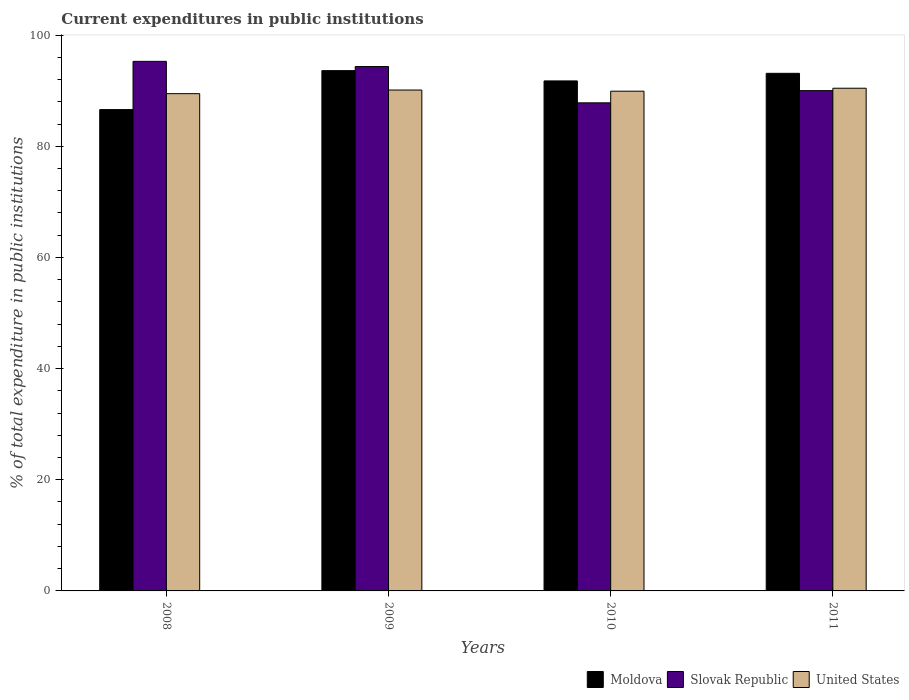How many different coloured bars are there?
Keep it short and to the point. 3. How many groups of bars are there?
Your answer should be compact. 4. How many bars are there on the 4th tick from the right?
Provide a short and direct response. 3. What is the label of the 1st group of bars from the left?
Your answer should be very brief. 2008. What is the current expenditures in public institutions in United States in 2010?
Offer a very short reply. 89.91. Across all years, what is the maximum current expenditures in public institutions in Slovak Republic?
Your answer should be very brief. 95.28. Across all years, what is the minimum current expenditures in public institutions in United States?
Offer a terse response. 89.47. In which year was the current expenditures in public institutions in Slovak Republic minimum?
Offer a very short reply. 2010. What is the total current expenditures in public institutions in United States in the graph?
Provide a succinct answer. 359.94. What is the difference between the current expenditures in public institutions in United States in 2010 and that in 2011?
Offer a very short reply. -0.53. What is the difference between the current expenditures in public institutions in Slovak Republic in 2011 and the current expenditures in public institutions in Moldova in 2008?
Provide a short and direct response. 3.41. What is the average current expenditures in public institutions in United States per year?
Provide a short and direct response. 89.99. In the year 2011, what is the difference between the current expenditures in public institutions in United States and current expenditures in public institutions in Moldova?
Your response must be concise. -2.68. What is the ratio of the current expenditures in public institutions in United States in 2010 to that in 2011?
Offer a terse response. 0.99. Is the difference between the current expenditures in public institutions in United States in 2010 and 2011 greater than the difference between the current expenditures in public institutions in Moldova in 2010 and 2011?
Provide a succinct answer. Yes. What is the difference between the highest and the second highest current expenditures in public institutions in United States?
Offer a very short reply. 0.32. What is the difference between the highest and the lowest current expenditures in public institutions in Slovak Republic?
Offer a terse response. 7.46. In how many years, is the current expenditures in public institutions in Moldova greater than the average current expenditures in public institutions in Moldova taken over all years?
Provide a short and direct response. 3. Is the sum of the current expenditures in public institutions in Slovak Republic in 2010 and 2011 greater than the maximum current expenditures in public institutions in United States across all years?
Offer a terse response. Yes. What does the 2nd bar from the left in 2009 represents?
Your response must be concise. Slovak Republic. What does the 2nd bar from the right in 2009 represents?
Your answer should be compact. Slovak Republic. How many bars are there?
Ensure brevity in your answer.  12. How many years are there in the graph?
Give a very brief answer. 4. What is the difference between two consecutive major ticks on the Y-axis?
Make the answer very short. 20. How are the legend labels stacked?
Offer a very short reply. Horizontal. What is the title of the graph?
Provide a short and direct response. Current expenditures in public institutions. Does "Guinea" appear as one of the legend labels in the graph?
Ensure brevity in your answer.  No. What is the label or title of the Y-axis?
Keep it short and to the point. % of total expenditure in public institutions. What is the % of total expenditure in public institutions of Moldova in 2008?
Your answer should be compact. 86.6. What is the % of total expenditure in public institutions of Slovak Republic in 2008?
Provide a succinct answer. 95.28. What is the % of total expenditure in public institutions of United States in 2008?
Provide a succinct answer. 89.47. What is the % of total expenditure in public institutions of Moldova in 2009?
Keep it short and to the point. 93.61. What is the % of total expenditure in public institutions of Slovak Republic in 2009?
Provide a succinct answer. 94.35. What is the % of total expenditure in public institutions of United States in 2009?
Offer a terse response. 90.12. What is the % of total expenditure in public institutions in Moldova in 2010?
Keep it short and to the point. 91.76. What is the % of total expenditure in public institutions of Slovak Republic in 2010?
Give a very brief answer. 87.82. What is the % of total expenditure in public institutions in United States in 2010?
Ensure brevity in your answer.  89.91. What is the % of total expenditure in public institutions of Moldova in 2011?
Make the answer very short. 93.13. What is the % of total expenditure in public institutions of Slovak Republic in 2011?
Provide a succinct answer. 90.01. What is the % of total expenditure in public institutions in United States in 2011?
Your answer should be compact. 90.44. Across all years, what is the maximum % of total expenditure in public institutions of Moldova?
Provide a succinct answer. 93.61. Across all years, what is the maximum % of total expenditure in public institutions in Slovak Republic?
Ensure brevity in your answer.  95.28. Across all years, what is the maximum % of total expenditure in public institutions in United States?
Ensure brevity in your answer.  90.44. Across all years, what is the minimum % of total expenditure in public institutions of Moldova?
Your answer should be compact. 86.6. Across all years, what is the minimum % of total expenditure in public institutions of Slovak Republic?
Provide a short and direct response. 87.82. Across all years, what is the minimum % of total expenditure in public institutions of United States?
Give a very brief answer. 89.47. What is the total % of total expenditure in public institutions in Moldova in the graph?
Give a very brief answer. 365.1. What is the total % of total expenditure in public institutions in Slovak Republic in the graph?
Your answer should be very brief. 367.46. What is the total % of total expenditure in public institutions in United States in the graph?
Offer a terse response. 359.94. What is the difference between the % of total expenditure in public institutions of Moldova in 2008 and that in 2009?
Ensure brevity in your answer.  -7.01. What is the difference between the % of total expenditure in public institutions in Slovak Republic in 2008 and that in 2009?
Provide a succinct answer. 0.93. What is the difference between the % of total expenditure in public institutions in United States in 2008 and that in 2009?
Your response must be concise. -0.65. What is the difference between the % of total expenditure in public institutions of Moldova in 2008 and that in 2010?
Provide a succinct answer. -5.16. What is the difference between the % of total expenditure in public institutions in Slovak Republic in 2008 and that in 2010?
Keep it short and to the point. 7.46. What is the difference between the % of total expenditure in public institutions in United States in 2008 and that in 2010?
Make the answer very short. -0.45. What is the difference between the % of total expenditure in public institutions of Moldova in 2008 and that in 2011?
Give a very brief answer. -6.53. What is the difference between the % of total expenditure in public institutions in Slovak Republic in 2008 and that in 2011?
Offer a terse response. 5.27. What is the difference between the % of total expenditure in public institutions of United States in 2008 and that in 2011?
Give a very brief answer. -0.98. What is the difference between the % of total expenditure in public institutions in Moldova in 2009 and that in 2010?
Your answer should be compact. 1.85. What is the difference between the % of total expenditure in public institutions in Slovak Republic in 2009 and that in 2010?
Offer a terse response. 6.53. What is the difference between the % of total expenditure in public institutions of United States in 2009 and that in 2010?
Your answer should be very brief. 0.21. What is the difference between the % of total expenditure in public institutions of Moldova in 2009 and that in 2011?
Ensure brevity in your answer.  0.48. What is the difference between the % of total expenditure in public institutions of Slovak Republic in 2009 and that in 2011?
Offer a very short reply. 4.33. What is the difference between the % of total expenditure in public institutions of United States in 2009 and that in 2011?
Your response must be concise. -0.32. What is the difference between the % of total expenditure in public institutions of Moldova in 2010 and that in 2011?
Provide a short and direct response. -1.37. What is the difference between the % of total expenditure in public institutions in Slovak Republic in 2010 and that in 2011?
Offer a very short reply. -2.19. What is the difference between the % of total expenditure in public institutions in United States in 2010 and that in 2011?
Make the answer very short. -0.53. What is the difference between the % of total expenditure in public institutions in Moldova in 2008 and the % of total expenditure in public institutions in Slovak Republic in 2009?
Provide a short and direct response. -7.74. What is the difference between the % of total expenditure in public institutions in Moldova in 2008 and the % of total expenditure in public institutions in United States in 2009?
Keep it short and to the point. -3.52. What is the difference between the % of total expenditure in public institutions in Slovak Republic in 2008 and the % of total expenditure in public institutions in United States in 2009?
Offer a very short reply. 5.16. What is the difference between the % of total expenditure in public institutions in Moldova in 2008 and the % of total expenditure in public institutions in Slovak Republic in 2010?
Your response must be concise. -1.22. What is the difference between the % of total expenditure in public institutions in Moldova in 2008 and the % of total expenditure in public institutions in United States in 2010?
Your response must be concise. -3.31. What is the difference between the % of total expenditure in public institutions in Slovak Republic in 2008 and the % of total expenditure in public institutions in United States in 2010?
Offer a very short reply. 5.37. What is the difference between the % of total expenditure in public institutions of Moldova in 2008 and the % of total expenditure in public institutions of Slovak Republic in 2011?
Offer a terse response. -3.41. What is the difference between the % of total expenditure in public institutions of Moldova in 2008 and the % of total expenditure in public institutions of United States in 2011?
Your answer should be very brief. -3.84. What is the difference between the % of total expenditure in public institutions of Slovak Republic in 2008 and the % of total expenditure in public institutions of United States in 2011?
Your answer should be very brief. 4.84. What is the difference between the % of total expenditure in public institutions of Moldova in 2009 and the % of total expenditure in public institutions of Slovak Republic in 2010?
Offer a very short reply. 5.79. What is the difference between the % of total expenditure in public institutions of Moldova in 2009 and the % of total expenditure in public institutions of United States in 2010?
Your answer should be very brief. 3.7. What is the difference between the % of total expenditure in public institutions in Slovak Republic in 2009 and the % of total expenditure in public institutions in United States in 2010?
Provide a short and direct response. 4.44. What is the difference between the % of total expenditure in public institutions in Moldova in 2009 and the % of total expenditure in public institutions in Slovak Republic in 2011?
Your response must be concise. 3.6. What is the difference between the % of total expenditure in public institutions in Moldova in 2009 and the % of total expenditure in public institutions in United States in 2011?
Offer a terse response. 3.17. What is the difference between the % of total expenditure in public institutions of Slovak Republic in 2009 and the % of total expenditure in public institutions of United States in 2011?
Keep it short and to the point. 3.9. What is the difference between the % of total expenditure in public institutions of Moldova in 2010 and the % of total expenditure in public institutions of Slovak Republic in 2011?
Your answer should be very brief. 1.75. What is the difference between the % of total expenditure in public institutions in Moldova in 2010 and the % of total expenditure in public institutions in United States in 2011?
Give a very brief answer. 1.32. What is the difference between the % of total expenditure in public institutions of Slovak Republic in 2010 and the % of total expenditure in public institutions of United States in 2011?
Make the answer very short. -2.63. What is the average % of total expenditure in public institutions of Moldova per year?
Your response must be concise. 91.28. What is the average % of total expenditure in public institutions of Slovak Republic per year?
Keep it short and to the point. 91.86. What is the average % of total expenditure in public institutions of United States per year?
Provide a succinct answer. 89.99. In the year 2008, what is the difference between the % of total expenditure in public institutions of Moldova and % of total expenditure in public institutions of Slovak Republic?
Your answer should be very brief. -8.68. In the year 2008, what is the difference between the % of total expenditure in public institutions in Moldova and % of total expenditure in public institutions in United States?
Provide a succinct answer. -2.86. In the year 2008, what is the difference between the % of total expenditure in public institutions in Slovak Republic and % of total expenditure in public institutions in United States?
Provide a short and direct response. 5.81. In the year 2009, what is the difference between the % of total expenditure in public institutions in Moldova and % of total expenditure in public institutions in Slovak Republic?
Provide a succinct answer. -0.74. In the year 2009, what is the difference between the % of total expenditure in public institutions of Moldova and % of total expenditure in public institutions of United States?
Your answer should be compact. 3.49. In the year 2009, what is the difference between the % of total expenditure in public institutions in Slovak Republic and % of total expenditure in public institutions in United States?
Ensure brevity in your answer.  4.23. In the year 2010, what is the difference between the % of total expenditure in public institutions of Moldova and % of total expenditure in public institutions of Slovak Republic?
Your answer should be compact. 3.94. In the year 2010, what is the difference between the % of total expenditure in public institutions of Moldova and % of total expenditure in public institutions of United States?
Your answer should be compact. 1.85. In the year 2010, what is the difference between the % of total expenditure in public institutions in Slovak Republic and % of total expenditure in public institutions in United States?
Your answer should be compact. -2.09. In the year 2011, what is the difference between the % of total expenditure in public institutions of Moldova and % of total expenditure in public institutions of Slovak Republic?
Provide a succinct answer. 3.12. In the year 2011, what is the difference between the % of total expenditure in public institutions of Moldova and % of total expenditure in public institutions of United States?
Offer a very short reply. 2.68. In the year 2011, what is the difference between the % of total expenditure in public institutions of Slovak Republic and % of total expenditure in public institutions of United States?
Keep it short and to the point. -0.43. What is the ratio of the % of total expenditure in public institutions of Moldova in 2008 to that in 2009?
Make the answer very short. 0.93. What is the ratio of the % of total expenditure in public institutions of Slovak Republic in 2008 to that in 2009?
Provide a short and direct response. 1.01. What is the ratio of the % of total expenditure in public institutions of United States in 2008 to that in 2009?
Keep it short and to the point. 0.99. What is the ratio of the % of total expenditure in public institutions in Moldova in 2008 to that in 2010?
Ensure brevity in your answer.  0.94. What is the ratio of the % of total expenditure in public institutions in Slovak Republic in 2008 to that in 2010?
Give a very brief answer. 1.08. What is the ratio of the % of total expenditure in public institutions in United States in 2008 to that in 2010?
Your answer should be very brief. 0.99. What is the ratio of the % of total expenditure in public institutions in Moldova in 2008 to that in 2011?
Offer a very short reply. 0.93. What is the ratio of the % of total expenditure in public institutions in Slovak Republic in 2008 to that in 2011?
Provide a short and direct response. 1.06. What is the ratio of the % of total expenditure in public institutions in Moldova in 2009 to that in 2010?
Your answer should be compact. 1.02. What is the ratio of the % of total expenditure in public institutions in Slovak Republic in 2009 to that in 2010?
Your response must be concise. 1.07. What is the ratio of the % of total expenditure in public institutions of United States in 2009 to that in 2010?
Provide a short and direct response. 1. What is the ratio of the % of total expenditure in public institutions in Slovak Republic in 2009 to that in 2011?
Give a very brief answer. 1.05. What is the ratio of the % of total expenditure in public institutions in United States in 2009 to that in 2011?
Keep it short and to the point. 1. What is the ratio of the % of total expenditure in public institutions in Moldova in 2010 to that in 2011?
Make the answer very short. 0.99. What is the ratio of the % of total expenditure in public institutions in Slovak Republic in 2010 to that in 2011?
Make the answer very short. 0.98. What is the ratio of the % of total expenditure in public institutions of United States in 2010 to that in 2011?
Offer a very short reply. 0.99. What is the difference between the highest and the second highest % of total expenditure in public institutions of Moldova?
Your answer should be compact. 0.48. What is the difference between the highest and the second highest % of total expenditure in public institutions in Slovak Republic?
Your answer should be very brief. 0.93. What is the difference between the highest and the second highest % of total expenditure in public institutions of United States?
Make the answer very short. 0.32. What is the difference between the highest and the lowest % of total expenditure in public institutions in Moldova?
Your response must be concise. 7.01. What is the difference between the highest and the lowest % of total expenditure in public institutions in Slovak Republic?
Make the answer very short. 7.46. What is the difference between the highest and the lowest % of total expenditure in public institutions of United States?
Your answer should be compact. 0.98. 